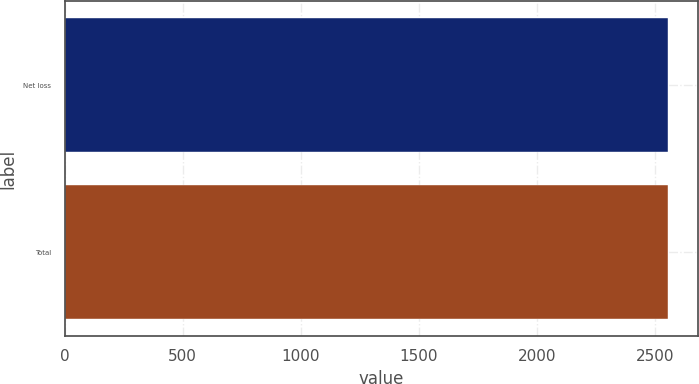Convert chart to OTSL. <chart><loc_0><loc_0><loc_500><loc_500><bar_chart><fcel>Net loss<fcel>Total<nl><fcel>2553<fcel>2553.1<nl></chart> 